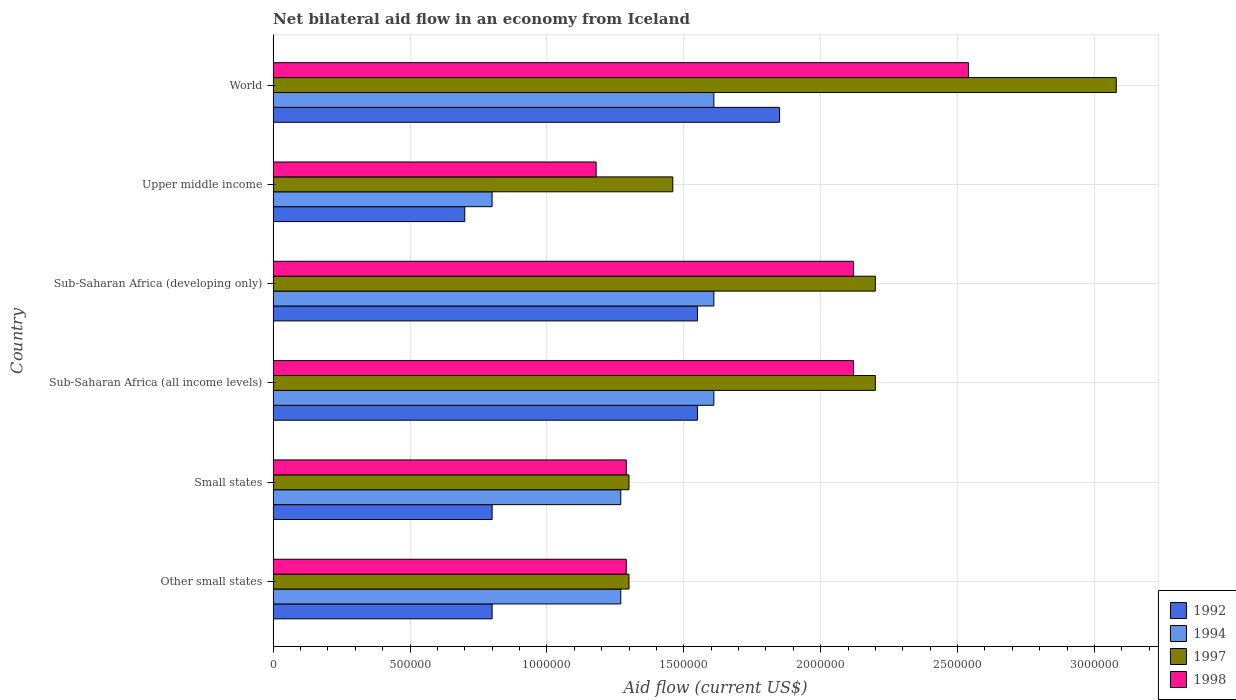How many different coloured bars are there?
Provide a short and direct response. 4. How many groups of bars are there?
Your response must be concise. 6. Are the number of bars on each tick of the Y-axis equal?
Offer a terse response. Yes. How many bars are there on the 3rd tick from the top?
Give a very brief answer. 4. What is the label of the 4th group of bars from the top?
Your answer should be very brief. Sub-Saharan Africa (all income levels). In how many cases, is the number of bars for a given country not equal to the number of legend labels?
Provide a short and direct response. 0. What is the net bilateral aid flow in 1992 in World?
Provide a succinct answer. 1.85e+06. Across all countries, what is the maximum net bilateral aid flow in 1992?
Make the answer very short. 1.85e+06. Across all countries, what is the minimum net bilateral aid flow in 1998?
Keep it short and to the point. 1.18e+06. In which country was the net bilateral aid flow in 1994 maximum?
Provide a short and direct response. Sub-Saharan Africa (all income levels). In which country was the net bilateral aid flow in 1997 minimum?
Your answer should be compact. Other small states. What is the total net bilateral aid flow in 1998 in the graph?
Ensure brevity in your answer.  1.05e+07. What is the difference between the net bilateral aid flow in 1998 in Other small states and that in World?
Your answer should be compact. -1.25e+06. What is the difference between the net bilateral aid flow in 1998 in Sub-Saharan Africa (developing only) and the net bilateral aid flow in 1997 in Other small states?
Your answer should be very brief. 8.20e+05. What is the average net bilateral aid flow in 1997 per country?
Your answer should be very brief. 1.92e+06. In how many countries, is the net bilateral aid flow in 1992 greater than 200000 US$?
Provide a short and direct response. 6. Is the net bilateral aid flow in 1998 in Upper middle income less than that in World?
Ensure brevity in your answer.  Yes. What is the difference between the highest and the lowest net bilateral aid flow in 1994?
Offer a terse response. 8.10e+05. In how many countries, is the net bilateral aid flow in 1992 greater than the average net bilateral aid flow in 1992 taken over all countries?
Keep it short and to the point. 3. Is the sum of the net bilateral aid flow in 1994 in Small states and Upper middle income greater than the maximum net bilateral aid flow in 1997 across all countries?
Give a very brief answer. No. Is it the case that in every country, the sum of the net bilateral aid flow in 1997 and net bilateral aid flow in 1998 is greater than the sum of net bilateral aid flow in 1992 and net bilateral aid flow in 1994?
Give a very brief answer. No. What does the 2nd bar from the top in Sub-Saharan Africa (developing only) represents?
Offer a very short reply. 1997. How many countries are there in the graph?
Provide a succinct answer. 6. What is the difference between two consecutive major ticks on the X-axis?
Your response must be concise. 5.00e+05. Are the values on the major ticks of X-axis written in scientific E-notation?
Provide a succinct answer. No. Does the graph contain any zero values?
Ensure brevity in your answer.  No. Where does the legend appear in the graph?
Offer a very short reply. Bottom right. How many legend labels are there?
Provide a short and direct response. 4. How are the legend labels stacked?
Give a very brief answer. Vertical. What is the title of the graph?
Offer a terse response. Net bilateral aid flow in an economy from Iceland. What is the Aid flow (current US$) of 1992 in Other small states?
Your response must be concise. 8.00e+05. What is the Aid flow (current US$) of 1994 in Other small states?
Your answer should be very brief. 1.27e+06. What is the Aid flow (current US$) in 1997 in Other small states?
Your answer should be compact. 1.30e+06. What is the Aid flow (current US$) of 1998 in Other small states?
Ensure brevity in your answer.  1.29e+06. What is the Aid flow (current US$) of 1994 in Small states?
Make the answer very short. 1.27e+06. What is the Aid flow (current US$) of 1997 in Small states?
Make the answer very short. 1.30e+06. What is the Aid flow (current US$) in 1998 in Small states?
Your answer should be very brief. 1.29e+06. What is the Aid flow (current US$) of 1992 in Sub-Saharan Africa (all income levels)?
Your answer should be very brief. 1.55e+06. What is the Aid flow (current US$) in 1994 in Sub-Saharan Africa (all income levels)?
Your answer should be very brief. 1.61e+06. What is the Aid flow (current US$) of 1997 in Sub-Saharan Africa (all income levels)?
Keep it short and to the point. 2.20e+06. What is the Aid flow (current US$) of 1998 in Sub-Saharan Africa (all income levels)?
Make the answer very short. 2.12e+06. What is the Aid flow (current US$) in 1992 in Sub-Saharan Africa (developing only)?
Offer a terse response. 1.55e+06. What is the Aid flow (current US$) in 1994 in Sub-Saharan Africa (developing only)?
Provide a short and direct response. 1.61e+06. What is the Aid flow (current US$) of 1997 in Sub-Saharan Africa (developing only)?
Give a very brief answer. 2.20e+06. What is the Aid flow (current US$) of 1998 in Sub-Saharan Africa (developing only)?
Ensure brevity in your answer.  2.12e+06. What is the Aid flow (current US$) in 1994 in Upper middle income?
Your answer should be compact. 8.00e+05. What is the Aid flow (current US$) in 1997 in Upper middle income?
Offer a terse response. 1.46e+06. What is the Aid flow (current US$) in 1998 in Upper middle income?
Make the answer very short. 1.18e+06. What is the Aid flow (current US$) of 1992 in World?
Offer a very short reply. 1.85e+06. What is the Aid flow (current US$) of 1994 in World?
Provide a succinct answer. 1.61e+06. What is the Aid flow (current US$) in 1997 in World?
Ensure brevity in your answer.  3.08e+06. What is the Aid flow (current US$) of 1998 in World?
Your answer should be very brief. 2.54e+06. Across all countries, what is the maximum Aid flow (current US$) of 1992?
Offer a terse response. 1.85e+06. Across all countries, what is the maximum Aid flow (current US$) of 1994?
Make the answer very short. 1.61e+06. Across all countries, what is the maximum Aid flow (current US$) in 1997?
Keep it short and to the point. 3.08e+06. Across all countries, what is the maximum Aid flow (current US$) in 1998?
Offer a very short reply. 2.54e+06. Across all countries, what is the minimum Aid flow (current US$) in 1992?
Give a very brief answer. 7.00e+05. Across all countries, what is the minimum Aid flow (current US$) in 1997?
Keep it short and to the point. 1.30e+06. Across all countries, what is the minimum Aid flow (current US$) of 1998?
Offer a very short reply. 1.18e+06. What is the total Aid flow (current US$) in 1992 in the graph?
Offer a terse response. 7.25e+06. What is the total Aid flow (current US$) of 1994 in the graph?
Make the answer very short. 8.17e+06. What is the total Aid flow (current US$) in 1997 in the graph?
Your answer should be very brief. 1.15e+07. What is the total Aid flow (current US$) of 1998 in the graph?
Keep it short and to the point. 1.05e+07. What is the difference between the Aid flow (current US$) of 1994 in Other small states and that in Small states?
Your response must be concise. 0. What is the difference between the Aid flow (current US$) of 1998 in Other small states and that in Small states?
Offer a very short reply. 0. What is the difference between the Aid flow (current US$) in 1992 in Other small states and that in Sub-Saharan Africa (all income levels)?
Make the answer very short. -7.50e+05. What is the difference between the Aid flow (current US$) in 1997 in Other small states and that in Sub-Saharan Africa (all income levels)?
Make the answer very short. -9.00e+05. What is the difference between the Aid flow (current US$) of 1998 in Other small states and that in Sub-Saharan Africa (all income levels)?
Provide a succinct answer. -8.30e+05. What is the difference between the Aid flow (current US$) in 1992 in Other small states and that in Sub-Saharan Africa (developing only)?
Provide a short and direct response. -7.50e+05. What is the difference between the Aid flow (current US$) of 1997 in Other small states and that in Sub-Saharan Africa (developing only)?
Your response must be concise. -9.00e+05. What is the difference between the Aid flow (current US$) of 1998 in Other small states and that in Sub-Saharan Africa (developing only)?
Provide a short and direct response. -8.30e+05. What is the difference between the Aid flow (current US$) in 1997 in Other small states and that in Upper middle income?
Your response must be concise. -1.60e+05. What is the difference between the Aid flow (current US$) in 1998 in Other small states and that in Upper middle income?
Give a very brief answer. 1.10e+05. What is the difference between the Aid flow (current US$) in 1992 in Other small states and that in World?
Provide a succinct answer. -1.05e+06. What is the difference between the Aid flow (current US$) of 1997 in Other small states and that in World?
Give a very brief answer. -1.78e+06. What is the difference between the Aid flow (current US$) of 1998 in Other small states and that in World?
Offer a terse response. -1.25e+06. What is the difference between the Aid flow (current US$) in 1992 in Small states and that in Sub-Saharan Africa (all income levels)?
Keep it short and to the point. -7.50e+05. What is the difference between the Aid flow (current US$) of 1997 in Small states and that in Sub-Saharan Africa (all income levels)?
Offer a very short reply. -9.00e+05. What is the difference between the Aid flow (current US$) in 1998 in Small states and that in Sub-Saharan Africa (all income levels)?
Make the answer very short. -8.30e+05. What is the difference between the Aid flow (current US$) of 1992 in Small states and that in Sub-Saharan Africa (developing only)?
Offer a terse response. -7.50e+05. What is the difference between the Aid flow (current US$) in 1997 in Small states and that in Sub-Saharan Africa (developing only)?
Your answer should be compact. -9.00e+05. What is the difference between the Aid flow (current US$) in 1998 in Small states and that in Sub-Saharan Africa (developing only)?
Offer a terse response. -8.30e+05. What is the difference between the Aid flow (current US$) in 1992 in Small states and that in Upper middle income?
Offer a very short reply. 1.00e+05. What is the difference between the Aid flow (current US$) of 1992 in Small states and that in World?
Make the answer very short. -1.05e+06. What is the difference between the Aid flow (current US$) in 1997 in Small states and that in World?
Your answer should be compact. -1.78e+06. What is the difference between the Aid flow (current US$) in 1998 in Small states and that in World?
Provide a succinct answer. -1.25e+06. What is the difference between the Aid flow (current US$) of 1992 in Sub-Saharan Africa (all income levels) and that in Sub-Saharan Africa (developing only)?
Your answer should be compact. 0. What is the difference between the Aid flow (current US$) in 1992 in Sub-Saharan Africa (all income levels) and that in Upper middle income?
Provide a succinct answer. 8.50e+05. What is the difference between the Aid flow (current US$) in 1994 in Sub-Saharan Africa (all income levels) and that in Upper middle income?
Your response must be concise. 8.10e+05. What is the difference between the Aid flow (current US$) in 1997 in Sub-Saharan Africa (all income levels) and that in Upper middle income?
Your answer should be compact. 7.40e+05. What is the difference between the Aid flow (current US$) of 1998 in Sub-Saharan Africa (all income levels) and that in Upper middle income?
Offer a terse response. 9.40e+05. What is the difference between the Aid flow (current US$) in 1992 in Sub-Saharan Africa (all income levels) and that in World?
Your answer should be very brief. -3.00e+05. What is the difference between the Aid flow (current US$) of 1997 in Sub-Saharan Africa (all income levels) and that in World?
Provide a short and direct response. -8.80e+05. What is the difference between the Aid flow (current US$) in 1998 in Sub-Saharan Africa (all income levels) and that in World?
Your answer should be very brief. -4.20e+05. What is the difference between the Aid flow (current US$) in 1992 in Sub-Saharan Africa (developing only) and that in Upper middle income?
Keep it short and to the point. 8.50e+05. What is the difference between the Aid flow (current US$) in 1994 in Sub-Saharan Africa (developing only) and that in Upper middle income?
Give a very brief answer. 8.10e+05. What is the difference between the Aid flow (current US$) of 1997 in Sub-Saharan Africa (developing only) and that in Upper middle income?
Offer a very short reply. 7.40e+05. What is the difference between the Aid flow (current US$) in 1998 in Sub-Saharan Africa (developing only) and that in Upper middle income?
Ensure brevity in your answer.  9.40e+05. What is the difference between the Aid flow (current US$) in 1994 in Sub-Saharan Africa (developing only) and that in World?
Offer a terse response. 0. What is the difference between the Aid flow (current US$) of 1997 in Sub-Saharan Africa (developing only) and that in World?
Keep it short and to the point. -8.80e+05. What is the difference between the Aid flow (current US$) in 1998 in Sub-Saharan Africa (developing only) and that in World?
Offer a very short reply. -4.20e+05. What is the difference between the Aid flow (current US$) in 1992 in Upper middle income and that in World?
Your answer should be compact. -1.15e+06. What is the difference between the Aid flow (current US$) of 1994 in Upper middle income and that in World?
Offer a very short reply. -8.10e+05. What is the difference between the Aid flow (current US$) of 1997 in Upper middle income and that in World?
Make the answer very short. -1.62e+06. What is the difference between the Aid flow (current US$) of 1998 in Upper middle income and that in World?
Make the answer very short. -1.36e+06. What is the difference between the Aid flow (current US$) of 1992 in Other small states and the Aid flow (current US$) of 1994 in Small states?
Your answer should be compact. -4.70e+05. What is the difference between the Aid flow (current US$) of 1992 in Other small states and the Aid flow (current US$) of 1997 in Small states?
Your answer should be very brief. -5.00e+05. What is the difference between the Aid flow (current US$) in 1992 in Other small states and the Aid flow (current US$) in 1998 in Small states?
Ensure brevity in your answer.  -4.90e+05. What is the difference between the Aid flow (current US$) of 1997 in Other small states and the Aid flow (current US$) of 1998 in Small states?
Your answer should be compact. 10000. What is the difference between the Aid flow (current US$) of 1992 in Other small states and the Aid flow (current US$) of 1994 in Sub-Saharan Africa (all income levels)?
Offer a terse response. -8.10e+05. What is the difference between the Aid flow (current US$) in 1992 in Other small states and the Aid flow (current US$) in 1997 in Sub-Saharan Africa (all income levels)?
Give a very brief answer. -1.40e+06. What is the difference between the Aid flow (current US$) of 1992 in Other small states and the Aid flow (current US$) of 1998 in Sub-Saharan Africa (all income levels)?
Provide a succinct answer. -1.32e+06. What is the difference between the Aid flow (current US$) of 1994 in Other small states and the Aid flow (current US$) of 1997 in Sub-Saharan Africa (all income levels)?
Offer a very short reply. -9.30e+05. What is the difference between the Aid flow (current US$) of 1994 in Other small states and the Aid flow (current US$) of 1998 in Sub-Saharan Africa (all income levels)?
Keep it short and to the point. -8.50e+05. What is the difference between the Aid flow (current US$) in 1997 in Other small states and the Aid flow (current US$) in 1998 in Sub-Saharan Africa (all income levels)?
Make the answer very short. -8.20e+05. What is the difference between the Aid flow (current US$) in 1992 in Other small states and the Aid flow (current US$) in 1994 in Sub-Saharan Africa (developing only)?
Keep it short and to the point. -8.10e+05. What is the difference between the Aid flow (current US$) in 1992 in Other small states and the Aid flow (current US$) in 1997 in Sub-Saharan Africa (developing only)?
Ensure brevity in your answer.  -1.40e+06. What is the difference between the Aid flow (current US$) in 1992 in Other small states and the Aid flow (current US$) in 1998 in Sub-Saharan Africa (developing only)?
Keep it short and to the point. -1.32e+06. What is the difference between the Aid flow (current US$) of 1994 in Other small states and the Aid flow (current US$) of 1997 in Sub-Saharan Africa (developing only)?
Provide a short and direct response. -9.30e+05. What is the difference between the Aid flow (current US$) in 1994 in Other small states and the Aid flow (current US$) in 1998 in Sub-Saharan Africa (developing only)?
Your answer should be very brief. -8.50e+05. What is the difference between the Aid flow (current US$) of 1997 in Other small states and the Aid flow (current US$) of 1998 in Sub-Saharan Africa (developing only)?
Keep it short and to the point. -8.20e+05. What is the difference between the Aid flow (current US$) of 1992 in Other small states and the Aid flow (current US$) of 1997 in Upper middle income?
Offer a very short reply. -6.60e+05. What is the difference between the Aid flow (current US$) in 1992 in Other small states and the Aid flow (current US$) in 1998 in Upper middle income?
Offer a very short reply. -3.80e+05. What is the difference between the Aid flow (current US$) of 1994 in Other small states and the Aid flow (current US$) of 1998 in Upper middle income?
Offer a very short reply. 9.00e+04. What is the difference between the Aid flow (current US$) of 1992 in Other small states and the Aid flow (current US$) of 1994 in World?
Your answer should be very brief. -8.10e+05. What is the difference between the Aid flow (current US$) of 1992 in Other small states and the Aid flow (current US$) of 1997 in World?
Your answer should be compact. -2.28e+06. What is the difference between the Aid flow (current US$) of 1992 in Other small states and the Aid flow (current US$) of 1998 in World?
Your response must be concise. -1.74e+06. What is the difference between the Aid flow (current US$) in 1994 in Other small states and the Aid flow (current US$) in 1997 in World?
Offer a very short reply. -1.81e+06. What is the difference between the Aid flow (current US$) of 1994 in Other small states and the Aid flow (current US$) of 1998 in World?
Keep it short and to the point. -1.27e+06. What is the difference between the Aid flow (current US$) in 1997 in Other small states and the Aid flow (current US$) in 1998 in World?
Offer a terse response. -1.24e+06. What is the difference between the Aid flow (current US$) of 1992 in Small states and the Aid flow (current US$) of 1994 in Sub-Saharan Africa (all income levels)?
Your answer should be compact. -8.10e+05. What is the difference between the Aid flow (current US$) of 1992 in Small states and the Aid flow (current US$) of 1997 in Sub-Saharan Africa (all income levels)?
Offer a very short reply. -1.40e+06. What is the difference between the Aid flow (current US$) in 1992 in Small states and the Aid flow (current US$) in 1998 in Sub-Saharan Africa (all income levels)?
Ensure brevity in your answer.  -1.32e+06. What is the difference between the Aid flow (current US$) in 1994 in Small states and the Aid flow (current US$) in 1997 in Sub-Saharan Africa (all income levels)?
Provide a short and direct response. -9.30e+05. What is the difference between the Aid flow (current US$) in 1994 in Small states and the Aid flow (current US$) in 1998 in Sub-Saharan Africa (all income levels)?
Your answer should be very brief. -8.50e+05. What is the difference between the Aid flow (current US$) of 1997 in Small states and the Aid flow (current US$) of 1998 in Sub-Saharan Africa (all income levels)?
Ensure brevity in your answer.  -8.20e+05. What is the difference between the Aid flow (current US$) in 1992 in Small states and the Aid flow (current US$) in 1994 in Sub-Saharan Africa (developing only)?
Your answer should be very brief. -8.10e+05. What is the difference between the Aid flow (current US$) of 1992 in Small states and the Aid flow (current US$) of 1997 in Sub-Saharan Africa (developing only)?
Your response must be concise. -1.40e+06. What is the difference between the Aid flow (current US$) of 1992 in Small states and the Aid flow (current US$) of 1998 in Sub-Saharan Africa (developing only)?
Provide a short and direct response. -1.32e+06. What is the difference between the Aid flow (current US$) of 1994 in Small states and the Aid flow (current US$) of 1997 in Sub-Saharan Africa (developing only)?
Your response must be concise. -9.30e+05. What is the difference between the Aid flow (current US$) in 1994 in Small states and the Aid flow (current US$) in 1998 in Sub-Saharan Africa (developing only)?
Give a very brief answer. -8.50e+05. What is the difference between the Aid flow (current US$) of 1997 in Small states and the Aid flow (current US$) of 1998 in Sub-Saharan Africa (developing only)?
Offer a terse response. -8.20e+05. What is the difference between the Aid flow (current US$) in 1992 in Small states and the Aid flow (current US$) in 1994 in Upper middle income?
Ensure brevity in your answer.  0. What is the difference between the Aid flow (current US$) in 1992 in Small states and the Aid flow (current US$) in 1997 in Upper middle income?
Give a very brief answer. -6.60e+05. What is the difference between the Aid flow (current US$) in 1992 in Small states and the Aid flow (current US$) in 1998 in Upper middle income?
Make the answer very short. -3.80e+05. What is the difference between the Aid flow (current US$) of 1994 in Small states and the Aid flow (current US$) of 1998 in Upper middle income?
Offer a terse response. 9.00e+04. What is the difference between the Aid flow (current US$) of 1992 in Small states and the Aid flow (current US$) of 1994 in World?
Your answer should be very brief. -8.10e+05. What is the difference between the Aid flow (current US$) of 1992 in Small states and the Aid flow (current US$) of 1997 in World?
Offer a terse response. -2.28e+06. What is the difference between the Aid flow (current US$) of 1992 in Small states and the Aid flow (current US$) of 1998 in World?
Keep it short and to the point. -1.74e+06. What is the difference between the Aid flow (current US$) in 1994 in Small states and the Aid flow (current US$) in 1997 in World?
Your answer should be compact. -1.81e+06. What is the difference between the Aid flow (current US$) in 1994 in Small states and the Aid flow (current US$) in 1998 in World?
Give a very brief answer. -1.27e+06. What is the difference between the Aid flow (current US$) in 1997 in Small states and the Aid flow (current US$) in 1998 in World?
Provide a short and direct response. -1.24e+06. What is the difference between the Aid flow (current US$) of 1992 in Sub-Saharan Africa (all income levels) and the Aid flow (current US$) of 1997 in Sub-Saharan Africa (developing only)?
Provide a short and direct response. -6.50e+05. What is the difference between the Aid flow (current US$) in 1992 in Sub-Saharan Africa (all income levels) and the Aid flow (current US$) in 1998 in Sub-Saharan Africa (developing only)?
Give a very brief answer. -5.70e+05. What is the difference between the Aid flow (current US$) in 1994 in Sub-Saharan Africa (all income levels) and the Aid flow (current US$) in 1997 in Sub-Saharan Africa (developing only)?
Offer a terse response. -5.90e+05. What is the difference between the Aid flow (current US$) of 1994 in Sub-Saharan Africa (all income levels) and the Aid flow (current US$) of 1998 in Sub-Saharan Africa (developing only)?
Give a very brief answer. -5.10e+05. What is the difference between the Aid flow (current US$) in 1992 in Sub-Saharan Africa (all income levels) and the Aid flow (current US$) in 1994 in Upper middle income?
Offer a terse response. 7.50e+05. What is the difference between the Aid flow (current US$) of 1992 in Sub-Saharan Africa (all income levels) and the Aid flow (current US$) of 1997 in Upper middle income?
Your answer should be compact. 9.00e+04. What is the difference between the Aid flow (current US$) of 1992 in Sub-Saharan Africa (all income levels) and the Aid flow (current US$) of 1998 in Upper middle income?
Give a very brief answer. 3.70e+05. What is the difference between the Aid flow (current US$) in 1994 in Sub-Saharan Africa (all income levels) and the Aid flow (current US$) in 1997 in Upper middle income?
Keep it short and to the point. 1.50e+05. What is the difference between the Aid flow (current US$) in 1994 in Sub-Saharan Africa (all income levels) and the Aid flow (current US$) in 1998 in Upper middle income?
Offer a very short reply. 4.30e+05. What is the difference between the Aid flow (current US$) of 1997 in Sub-Saharan Africa (all income levels) and the Aid flow (current US$) of 1998 in Upper middle income?
Your answer should be compact. 1.02e+06. What is the difference between the Aid flow (current US$) of 1992 in Sub-Saharan Africa (all income levels) and the Aid flow (current US$) of 1997 in World?
Offer a very short reply. -1.53e+06. What is the difference between the Aid flow (current US$) of 1992 in Sub-Saharan Africa (all income levels) and the Aid flow (current US$) of 1998 in World?
Your answer should be compact. -9.90e+05. What is the difference between the Aid flow (current US$) in 1994 in Sub-Saharan Africa (all income levels) and the Aid flow (current US$) in 1997 in World?
Your answer should be compact. -1.47e+06. What is the difference between the Aid flow (current US$) of 1994 in Sub-Saharan Africa (all income levels) and the Aid flow (current US$) of 1998 in World?
Offer a terse response. -9.30e+05. What is the difference between the Aid flow (current US$) of 1992 in Sub-Saharan Africa (developing only) and the Aid flow (current US$) of 1994 in Upper middle income?
Ensure brevity in your answer.  7.50e+05. What is the difference between the Aid flow (current US$) of 1994 in Sub-Saharan Africa (developing only) and the Aid flow (current US$) of 1998 in Upper middle income?
Offer a very short reply. 4.30e+05. What is the difference between the Aid flow (current US$) of 1997 in Sub-Saharan Africa (developing only) and the Aid flow (current US$) of 1998 in Upper middle income?
Offer a terse response. 1.02e+06. What is the difference between the Aid flow (current US$) in 1992 in Sub-Saharan Africa (developing only) and the Aid flow (current US$) in 1997 in World?
Offer a very short reply. -1.53e+06. What is the difference between the Aid flow (current US$) in 1992 in Sub-Saharan Africa (developing only) and the Aid flow (current US$) in 1998 in World?
Provide a short and direct response. -9.90e+05. What is the difference between the Aid flow (current US$) in 1994 in Sub-Saharan Africa (developing only) and the Aid flow (current US$) in 1997 in World?
Your answer should be very brief. -1.47e+06. What is the difference between the Aid flow (current US$) of 1994 in Sub-Saharan Africa (developing only) and the Aid flow (current US$) of 1998 in World?
Make the answer very short. -9.30e+05. What is the difference between the Aid flow (current US$) of 1992 in Upper middle income and the Aid flow (current US$) of 1994 in World?
Offer a terse response. -9.10e+05. What is the difference between the Aid flow (current US$) in 1992 in Upper middle income and the Aid flow (current US$) in 1997 in World?
Your answer should be very brief. -2.38e+06. What is the difference between the Aid flow (current US$) of 1992 in Upper middle income and the Aid flow (current US$) of 1998 in World?
Make the answer very short. -1.84e+06. What is the difference between the Aid flow (current US$) in 1994 in Upper middle income and the Aid flow (current US$) in 1997 in World?
Give a very brief answer. -2.28e+06. What is the difference between the Aid flow (current US$) of 1994 in Upper middle income and the Aid flow (current US$) of 1998 in World?
Your answer should be compact. -1.74e+06. What is the difference between the Aid flow (current US$) of 1997 in Upper middle income and the Aid flow (current US$) of 1998 in World?
Your answer should be compact. -1.08e+06. What is the average Aid flow (current US$) of 1992 per country?
Give a very brief answer. 1.21e+06. What is the average Aid flow (current US$) of 1994 per country?
Give a very brief answer. 1.36e+06. What is the average Aid flow (current US$) in 1997 per country?
Give a very brief answer. 1.92e+06. What is the average Aid flow (current US$) of 1998 per country?
Give a very brief answer. 1.76e+06. What is the difference between the Aid flow (current US$) in 1992 and Aid flow (current US$) in 1994 in Other small states?
Keep it short and to the point. -4.70e+05. What is the difference between the Aid flow (current US$) in 1992 and Aid flow (current US$) in 1997 in Other small states?
Offer a terse response. -5.00e+05. What is the difference between the Aid flow (current US$) in 1992 and Aid flow (current US$) in 1998 in Other small states?
Make the answer very short. -4.90e+05. What is the difference between the Aid flow (current US$) in 1994 and Aid flow (current US$) in 1997 in Other small states?
Offer a terse response. -3.00e+04. What is the difference between the Aid flow (current US$) of 1994 and Aid flow (current US$) of 1998 in Other small states?
Offer a very short reply. -2.00e+04. What is the difference between the Aid flow (current US$) in 1997 and Aid flow (current US$) in 1998 in Other small states?
Keep it short and to the point. 10000. What is the difference between the Aid flow (current US$) in 1992 and Aid flow (current US$) in 1994 in Small states?
Offer a terse response. -4.70e+05. What is the difference between the Aid flow (current US$) in 1992 and Aid flow (current US$) in 1997 in Small states?
Your answer should be compact. -5.00e+05. What is the difference between the Aid flow (current US$) in 1992 and Aid flow (current US$) in 1998 in Small states?
Offer a terse response. -4.90e+05. What is the difference between the Aid flow (current US$) of 1994 and Aid flow (current US$) of 1997 in Small states?
Provide a short and direct response. -3.00e+04. What is the difference between the Aid flow (current US$) in 1992 and Aid flow (current US$) in 1997 in Sub-Saharan Africa (all income levels)?
Offer a very short reply. -6.50e+05. What is the difference between the Aid flow (current US$) of 1992 and Aid flow (current US$) of 1998 in Sub-Saharan Africa (all income levels)?
Your response must be concise. -5.70e+05. What is the difference between the Aid flow (current US$) of 1994 and Aid flow (current US$) of 1997 in Sub-Saharan Africa (all income levels)?
Make the answer very short. -5.90e+05. What is the difference between the Aid flow (current US$) in 1994 and Aid flow (current US$) in 1998 in Sub-Saharan Africa (all income levels)?
Your answer should be compact. -5.10e+05. What is the difference between the Aid flow (current US$) in 1997 and Aid flow (current US$) in 1998 in Sub-Saharan Africa (all income levels)?
Offer a terse response. 8.00e+04. What is the difference between the Aid flow (current US$) of 1992 and Aid flow (current US$) of 1994 in Sub-Saharan Africa (developing only)?
Your response must be concise. -6.00e+04. What is the difference between the Aid flow (current US$) of 1992 and Aid flow (current US$) of 1997 in Sub-Saharan Africa (developing only)?
Your answer should be compact. -6.50e+05. What is the difference between the Aid flow (current US$) of 1992 and Aid flow (current US$) of 1998 in Sub-Saharan Africa (developing only)?
Your response must be concise. -5.70e+05. What is the difference between the Aid flow (current US$) of 1994 and Aid flow (current US$) of 1997 in Sub-Saharan Africa (developing only)?
Offer a terse response. -5.90e+05. What is the difference between the Aid flow (current US$) of 1994 and Aid flow (current US$) of 1998 in Sub-Saharan Africa (developing only)?
Your answer should be compact. -5.10e+05. What is the difference between the Aid flow (current US$) of 1997 and Aid flow (current US$) of 1998 in Sub-Saharan Africa (developing only)?
Ensure brevity in your answer.  8.00e+04. What is the difference between the Aid flow (current US$) in 1992 and Aid flow (current US$) in 1994 in Upper middle income?
Give a very brief answer. -1.00e+05. What is the difference between the Aid flow (current US$) of 1992 and Aid flow (current US$) of 1997 in Upper middle income?
Your answer should be very brief. -7.60e+05. What is the difference between the Aid flow (current US$) in 1992 and Aid flow (current US$) in 1998 in Upper middle income?
Your answer should be compact. -4.80e+05. What is the difference between the Aid flow (current US$) in 1994 and Aid flow (current US$) in 1997 in Upper middle income?
Give a very brief answer. -6.60e+05. What is the difference between the Aid flow (current US$) of 1994 and Aid flow (current US$) of 1998 in Upper middle income?
Provide a short and direct response. -3.80e+05. What is the difference between the Aid flow (current US$) in 1997 and Aid flow (current US$) in 1998 in Upper middle income?
Offer a terse response. 2.80e+05. What is the difference between the Aid flow (current US$) in 1992 and Aid flow (current US$) in 1997 in World?
Your response must be concise. -1.23e+06. What is the difference between the Aid flow (current US$) in 1992 and Aid flow (current US$) in 1998 in World?
Ensure brevity in your answer.  -6.90e+05. What is the difference between the Aid flow (current US$) in 1994 and Aid flow (current US$) in 1997 in World?
Give a very brief answer. -1.47e+06. What is the difference between the Aid flow (current US$) in 1994 and Aid flow (current US$) in 1998 in World?
Provide a short and direct response. -9.30e+05. What is the difference between the Aid flow (current US$) in 1997 and Aid flow (current US$) in 1998 in World?
Offer a terse response. 5.40e+05. What is the ratio of the Aid flow (current US$) in 1992 in Other small states to that in Small states?
Offer a very short reply. 1. What is the ratio of the Aid flow (current US$) of 1992 in Other small states to that in Sub-Saharan Africa (all income levels)?
Offer a terse response. 0.52. What is the ratio of the Aid flow (current US$) in 1994 in Other small states to that in Sub-Saharan Africa (all income levels)?
Offer a very short reply. 0.79. What is the ratio of the Aid flow (current US$) of 1997 in Other small states to that in Sub-Saharan Africa (all income levels)?
Offer a terse response. 0.59. What is the ratio of the Aid flow (current US$) of 1998 in Other small states to that in Sub-Saharan Africa (all income levels)?
Offer a terse response. 0.61. What is the ratio of the Aid flow (current US$) in 1992 in Other small states to that in Sub-Saharan Africa (developing only)?
Offer a terse response. 0.52. What is the ratio of the Aid flow (current US$) in 1994 in Other small states to that in Sub-Saharan Africa (developing only)?
Provide a succinct answer. 0.79. What is the ratio of the Aid flow (current US$) of 1997 in Other small states to that in Sub-Saharan Africa (developing only)?
Provide a short and direct response. 0.59. What is the ratio of the Aid flow (current US$) in 1998 in Other small states to that in Sub-Saharan Africa (developing only)?
Make the answer very short. 0.61. What is the ratio of the Aid flow (current US$) of 1992 in Other small states to that in Upper middle income?
Provide a short and direct response. 1.14. What is the ratio of the Aid flow (current US$) in 1994 in Other small states to that in Upper middle income?
Your response must be concise. 1.59. What is the ratio of the Aid flow (current US$) in 1997 in Other small states to that in Upper middle income?
Your answer should be very brief. 0.89. What is the ratio of the Aid flow (current US$) of 1998 in Other small states to that in Upper middle income?
Offer a terse response. 1.09. What is the ratio of the Aid flow (current US$) of 1992 in Other small states to that in World?
Offer a very short reply. 0.43. What is the ratio of the Aid flow (current US$) of 1994 in Other small states to that in World?
Ensure brevity in your answer.  0.79. What is the ratio of the Aid flow (current US$) in 1997 in Other small states to that in World?
Your answer should be very brief. 0.42. What is the ratio of the Aid flow (current US$) of 1998 in Other small states to that in World?
Your response must be concise. 0.51. What is the ratio of the Aid flow (current US$) in 1992 in Small states to that in Sub-Saharan Africa (all income levels)?
Give a very brief answer. 0.52. What is the ratio of the Aid flow (current US$) in 1994 in Small states to that in Sub-Saharan Africa (all income levels)?
Your answer should be very brief. 0.79. What is the ratio of the Aid flow (current US$) of 1997 in Small states to that in Sub-Saharan Africa (all income levels)?
Give a very brief answer. 0.59. What is the ratio of the Aid flow (current US$) in 1998 in Small states to that in Sub-Saharan Africa (all income levels)?
Your response must be concise. 0.61. What is the ratio of the Aid flow (current US$) in 1992 in Small states to that in Sub-Saharan Africa (developing only)?
Offer a terse response. 0.52. What is the ratio of the Aid flow (current US$) of 1994 in Small states to that in Sub-Saharan Africa (developing only)?
Offer a very short reply. 0.79. What is the ratio of the Aid flow (current US$) in 1997 in Small states to that in Sub-Saharan Africa (developing only)?
Your answer should be very brief. 0.59. What is the ratio of the Aid flow (current US$) of 1998 in Small states to that in Sub-Saharan Africa (developing only)?
Offer a terse response. 0.61. What is the ratio of the Aid flow (current US$) of 1992 in Small states to that in Upper middle income?
Give a very brief answer. 1.14. What is the ratio of the Aid flow (current US$) in 1994 in Small states to that in Upper middle income?
Provide a short and direct response. 1.59. What is the ratio of the Aid flow (current US$) in 1997 in Small states to that in Upper middle income?
Your answer should be compact. 0.89. What is the ratio of the Aid flow (current US$) in 1998 in Small states to that in Upper middle income?
Provide a succinct answer. 1.09. What is the ratio of the Aid flow (current US$) of 1992 in Small states to that in World?
Provide a short and direct response. 0.43. What is the ratio of the Aid flow (current US$) in 1994 in Small states to that in World?
Offer a very short reply. 0.79. What is the ratio of the Aid flow (current US$) of 1997 in Small states to that in World?
Make the answer very short. 0.42. What is the ratio of the Aid flow (current US$) in 1998 in Small states to that in World?
Keep it short and to the point. 0.51. What is the ratio of the Aid flow (current US$) of 1994 in Sub-Saharan Africa (all income levels) to that in Sub-Saharan Africa (developing only)?
Offer a very short reply. 1. What is the ratio of the Aid flow (current US$) of 1997 in Sub-Saharan Africa (all income levels) to that in Sub-Saharan Africa (developing only)?
Your response must be concise. 1. What is the ratio of the Aid flow (current US$) of 1992 in Sub-Saharan Africa (all income levels) to that in Upper middle income?
Offer a very short reply. 2.21. What is the ratio of the Aid flow (current US$) of 1994 in Sub-Saharan Africa (all income levels) to that in Upper middle income?
Give a very brief answer. 2.01. What is the ratio of the Aid flow (current US$) in 1997 in Sub-Saharan Africa (all income levels) to that in Upper middle income?
Your answer should be compact. 1.51. What is the ratio of the Aid flow (current US$) of 1998 in Sub-Saharan Africa (all income levels) to that in Upper middle income?
Your answer should be compact. 1.8. What is the ratio of the Aid flow (current US$) in 1992 in Sub-Saharan Africa (all income levels) to that in World?
Ensure brevity in your answer.  0.84. What is the ratio of the Aid flow (current US$) in 1997 in Sub-Saharan Africa (all income levels) to that in World?
Keep it short and to the point. 0.71. What is the ratio of the Aid flow (current US$) of 1998 in Sub-Saharan Africa (all income levels) to that in World?
Make the answer very short. 0.83. What is the ratio of the Aid flow (current US$) in 1992 in Sub-Saharan Africa (developing only) to that in Upper middle income?
Keep it short and to the point. 2.21. What is the ratio of the Aid flow (current US$) in 1994 in Sub-Saharan Africa (developing only) to that in Upper middle income?
Your answer should be very brief. 2.01. What is the ratio of the Aid flow (current US$) of 1997 in Sub-Saharan Africa (developing only) to that in Upper middle income?
Ensure brevity in your answer.  1.51. What is the ratio of the Aid flow (current US$) of 1998 in Sub-Saharan Africa (developing only) to that in Upper middle income?
Your answer should be compact. 1.8. What is the ratio of the Aid flow (current US$) of 1992 in Sub-Saharan Africa (developing only) to that in World?
Ensure brevity in your answer.  0.84. What is the ratio of the Aid flow (current US$) of 1998 in Sub-Saharan Africa (developing only) to that in World?
Make the answer very short. 0.83. What is the ratio of the Aid flow (current US$) of 1992 in Upper middle income to that in World?
Your response must be concise. 0.38. What is the ratio of the Aid flow (current US$) in 1994 in Upper middle income to that in World?
Offer a terse response. 0.5. What is the ratio of the Aid flow (current US$) of 1997 in Upper middle income to that in World?
Your answer should be compact. 0.47. What is the ratio of the Aid flow (current US$) of 1998 in Upper middle income to that in World?
Make the answer very short. 0.46. What is the difference between the highest and the second highest Aid flow (current US$) in 1994?
Your answer should be very brief. 0. What is the difference between the highest and the second highest Aid flow (current US$) of 1997?
Make the answer very short. 8.80e+05. What is the difference between the highest and the second highest Aid flow (current US$) of 1998?
Keep it short and to the point. 4.20e+05. What is the difference between the highest and the lowest Aid flow (current US$) in 1992?
Offer a very short reply. 1.15e+06. What is the difference between the highest and the lowest Aid flow (current US$) of 1994?
Give a very brief answer. 8.10e+05. What is the difference between the highest and the lowest Aid flow (current US$) in 1997?
Ensure brevity in your answer.  1.78e+06. What is the difference between the highest and the lowest Aid flow (current US$) of 1998?
Your response must be concise. 1.36e+06. 